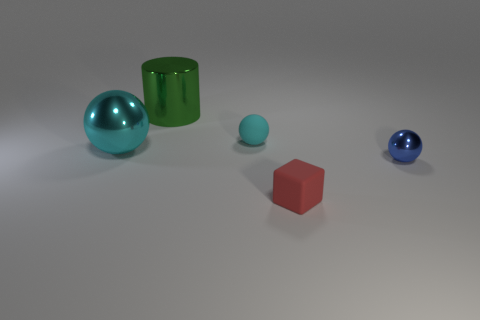Add 5 big purple cylinders. How many objects exist? 10 Subtract all tiny balls. How many balls are left? 1 Subtract all blue balls. How many balls are left? 2 Subtract 0 brown balls. How many objects are left? 5 Subtract all blocks. How many objects are left? 4 Subtract 2 spheres. How many spheres are left? 1 Subtract all gray cylinders. Subtract all red blocks. How many cylinders are left? 1 Subtract all brown cylinders. How many gray blocks are left? 0 Subtract all green things. Subtract all metal cylinders. How many objects are left? 3 Add 5 big metallic spheres. How many big metallic spheres are left? 6 